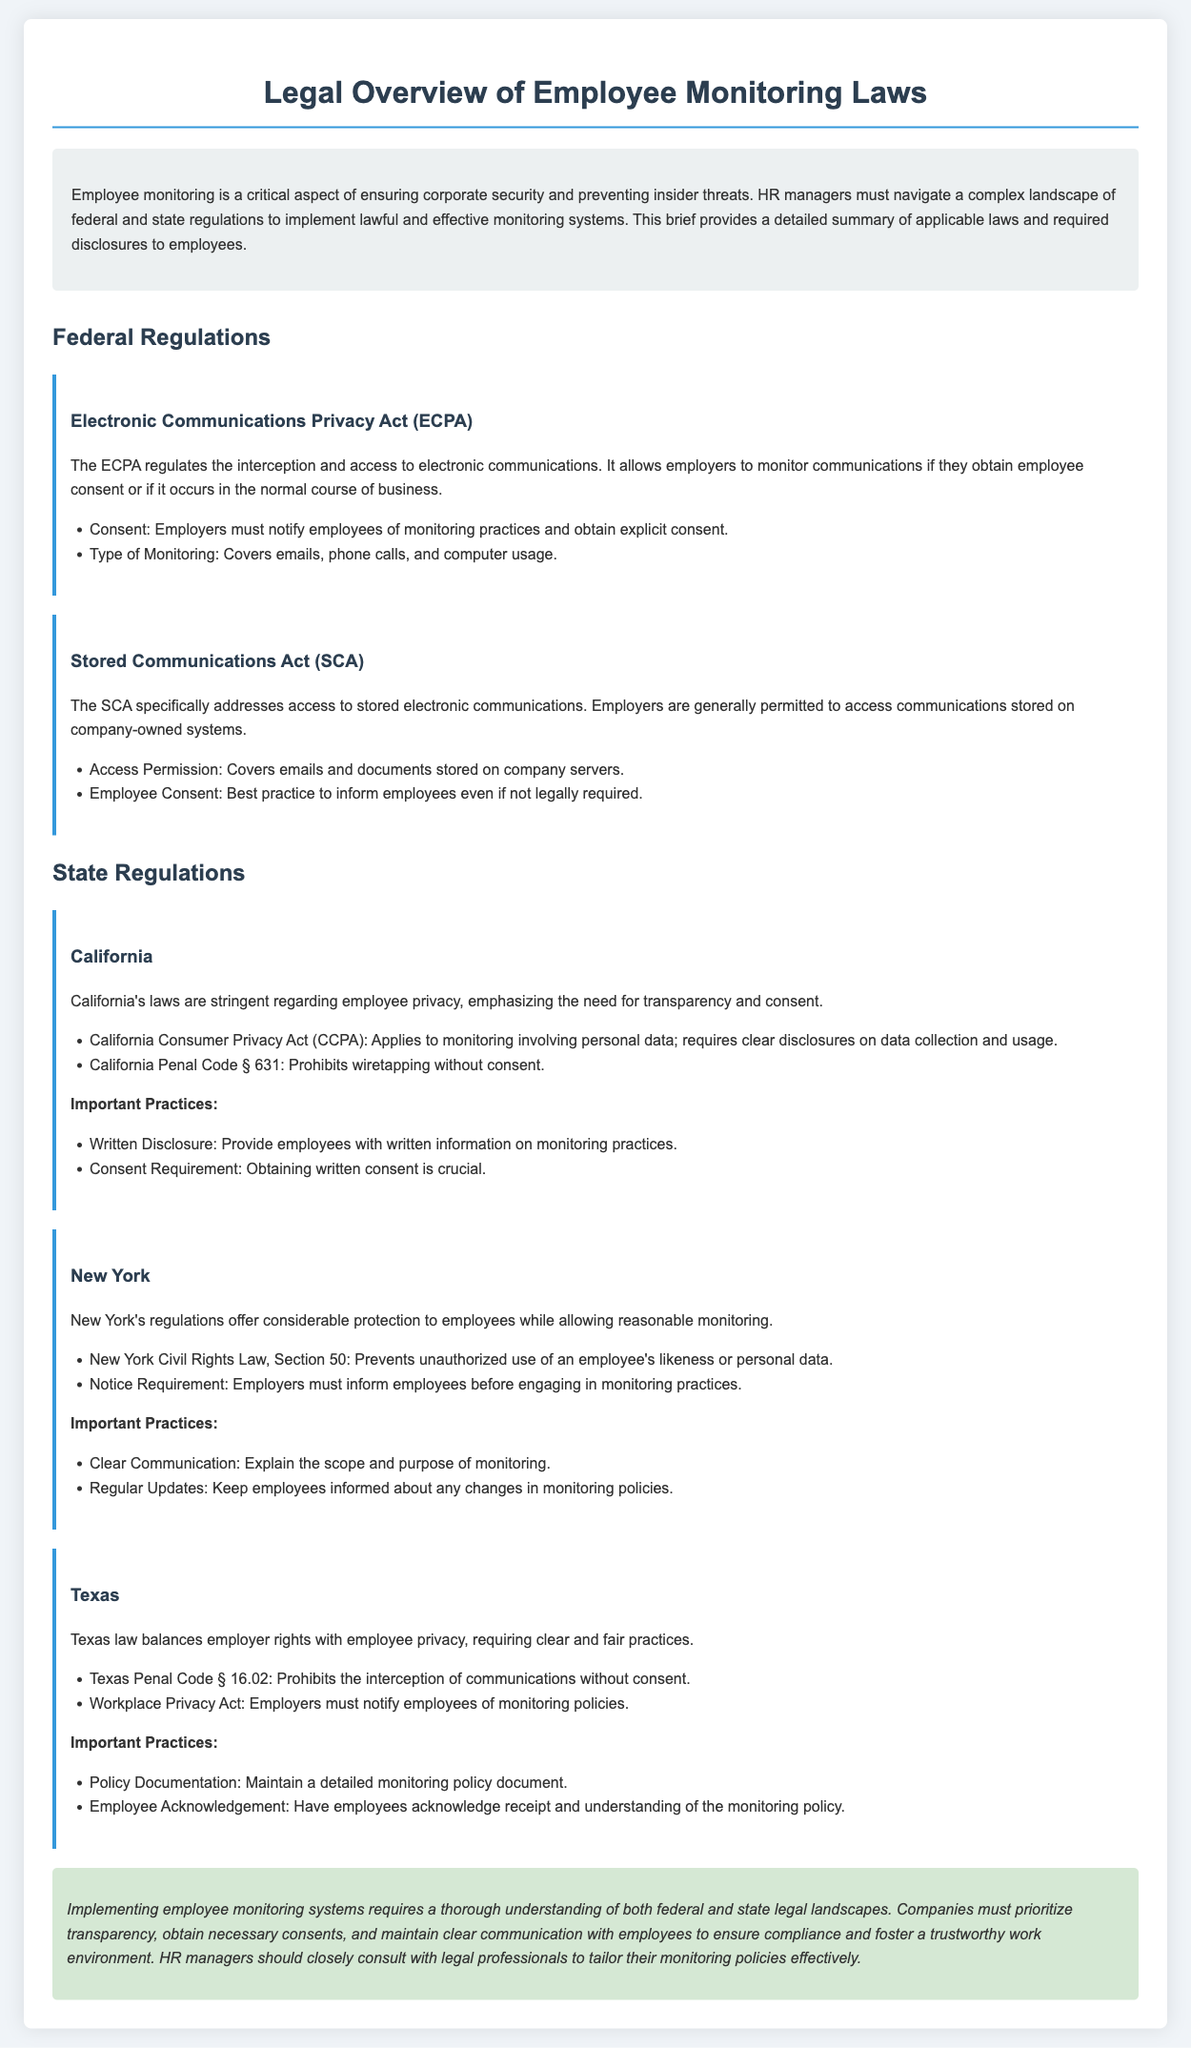what is the main purpose of employee monitoring? The main purpose is ensuring corporate security and preventing insider threats.
Answer: ensuring corporate security and preventing insider threats which federal act regulates the interception of electronic communications? The act that regulates interception is the Electronic Communications Privacy Act (ECPA).
Answer: Electronic Communications Privacy Act (ECPA) what type of consent is required by the ECPA for monitoring practices? The ECPA requires explicit consent from employees before monitoring practices can begin.
Answer: explicit consent which state requires clear disclosures on data collection under its privacy law? California requires clear disclosures on data collection under the California Consumer Privacy Act (CCPA).
Answer: California which document outlines employee rights concerning unauthorized use of likeness in New York? The New York Civil Rights Law, Section 50 addresses unauthorized use of employee likeness.
Answer: New York Civil Rights Law, Section 50 what is a key recommended practice in Texas for monitoring policies? A key recommended practice in Texas is to maintain a detailed monitoring policy document.
Answer: maintain a detailed monitoring policy document what does the conclusion emphasize for HR managers? The conclusion emphasizes prioritizing transparency and obtaining necessary consents.
Answer: prioritizing transparency and obtaining necessary consents how does California law view employee privacy in monitoring practices? California law emphasizes the need for transparency and consent regarding employee privacy.
Answer: the need for transparency and consent what is a necessary practice before engaging in monitoring according to New York regulations? Employers must inform employees before engaging in monitoring practices.
Answer: inform employees 